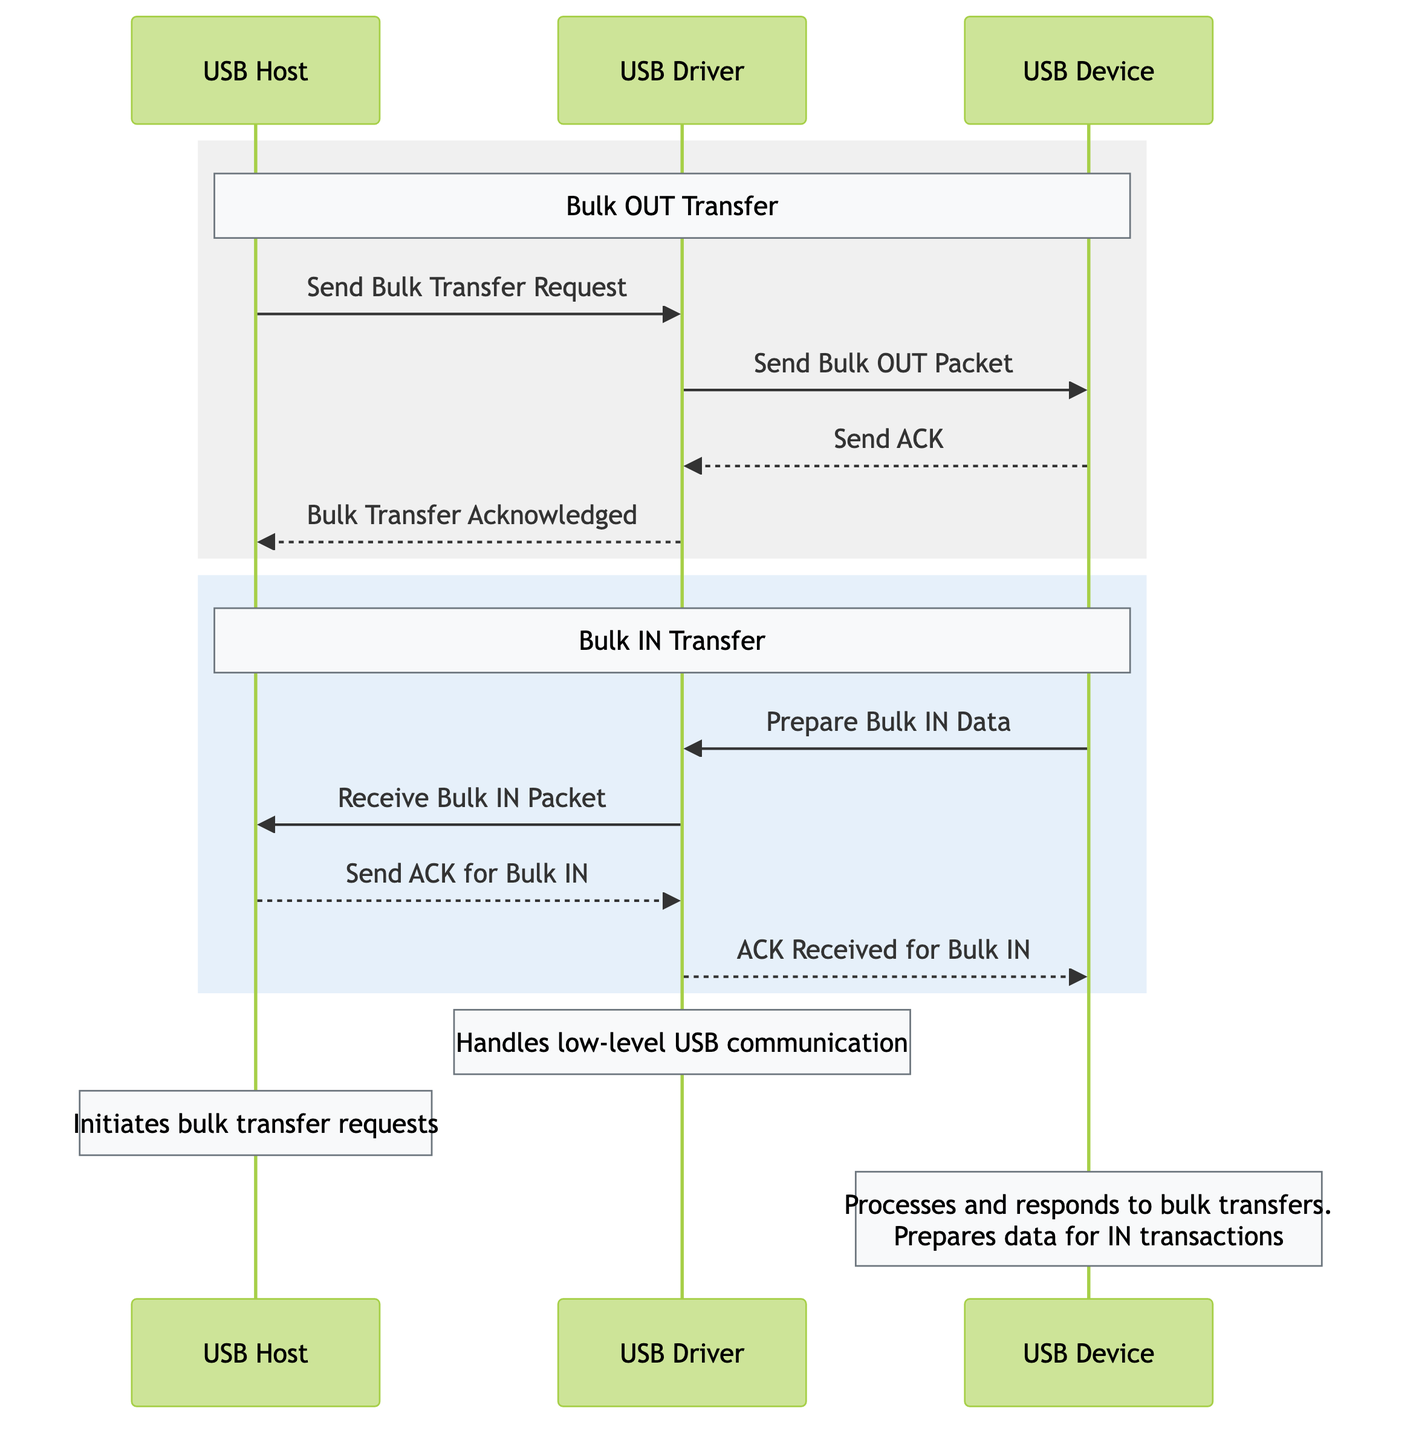What are the three main actors in the diagram? The actors indicated in the diagram are "USB Host," "USB Device," and "USB Driver." By looking at the diagram, we can clearly identify these three participants as they are labeled at the top of the diagram.
Answer: USB Host, USB Device, USB Driver How many messages are exchanged during the Bulk OUT transfer? In the Bulk OUT transfer section of the diagram, we find four messages exchanged: "Send Bulk Transfer Request," "Send Bulk OUT Packet," "Send ACK," and "Bulk Transfer Acknowledged." We count all four arrows in this section to determine the total.
Answer: 4 What is the first message sent in the Bulk IN transfer? The first message in the Bulk IN transfer, indicated in the corresponding section, is "Prepare Bulk IN Data." This message is sent from the USB Device to the USB Driver, as shown in the diagram's sequence flow.
Answer: Prepare Bulk IN Data Which actor initiates the bulk transfer requests? The diagram explicitly notes that the "USB Host" initiates the bulk transfer requests. This is reinforced by the labeling found within the notes section of the diagram.
Answer: USB Host How many total messages are exchanged in the entire diagram? Counting all messages in both sections (Bulk OUT and Bulk IN), we have a total of eight messages: the four from Bulk OUT and four from Bulk IN. Thus, by summing these, we reach the total count.
Answer: 8 What acknowledgment does the USB Host send in the Bulk IN transfer? During the Bulk IN transfer, the USB Host sends an acknowledgment message called "Send ACK for Bulk IN." This is clearly indicated by an arrow directed from the USB Host to the USB Driver in the flow.
Answer: Send ACK for Bulk IN What role does the USB Driver play according to the diagram's note? According to the note attached to the USB Driver, its role is to "Handle low-level USB communication." This is a key responsibility defined in the details present in the diagram.
Answer: Handle low-level USB communication Identify the message sent from the USB Device back to the USB Driver in response to receiving a packet. The message sent back from the USB Device to the USB Driver is "Send ACK." This is within the Bulk OUT transfer process, as per the corresponding sequence in the diagram.
Answer: Send ACK 